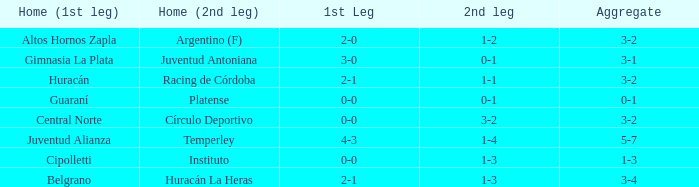Which team played the 2nd leg at home with a tie of 1-1 and scored 3-2 in aggregate? Racing de Córdoba. 